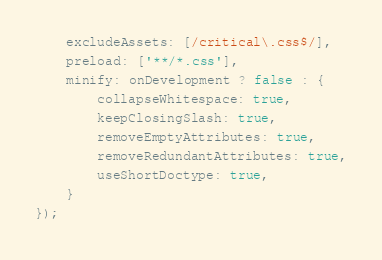<code> <loc_0><loc_0><loc_500><loc_500><_JavaScript_>    excludeAssets: [/critical\.css$/],
    preload: ['**/*.css'],
    minify: onDevelopment ? false : {
        collapseWhitespace: true,
        keepClosingSlash: true,
        removeEmptyAttributes: true,
        removeRedundantAttributes: true,
        useShortDoctype: true,
    }
});
</code> 